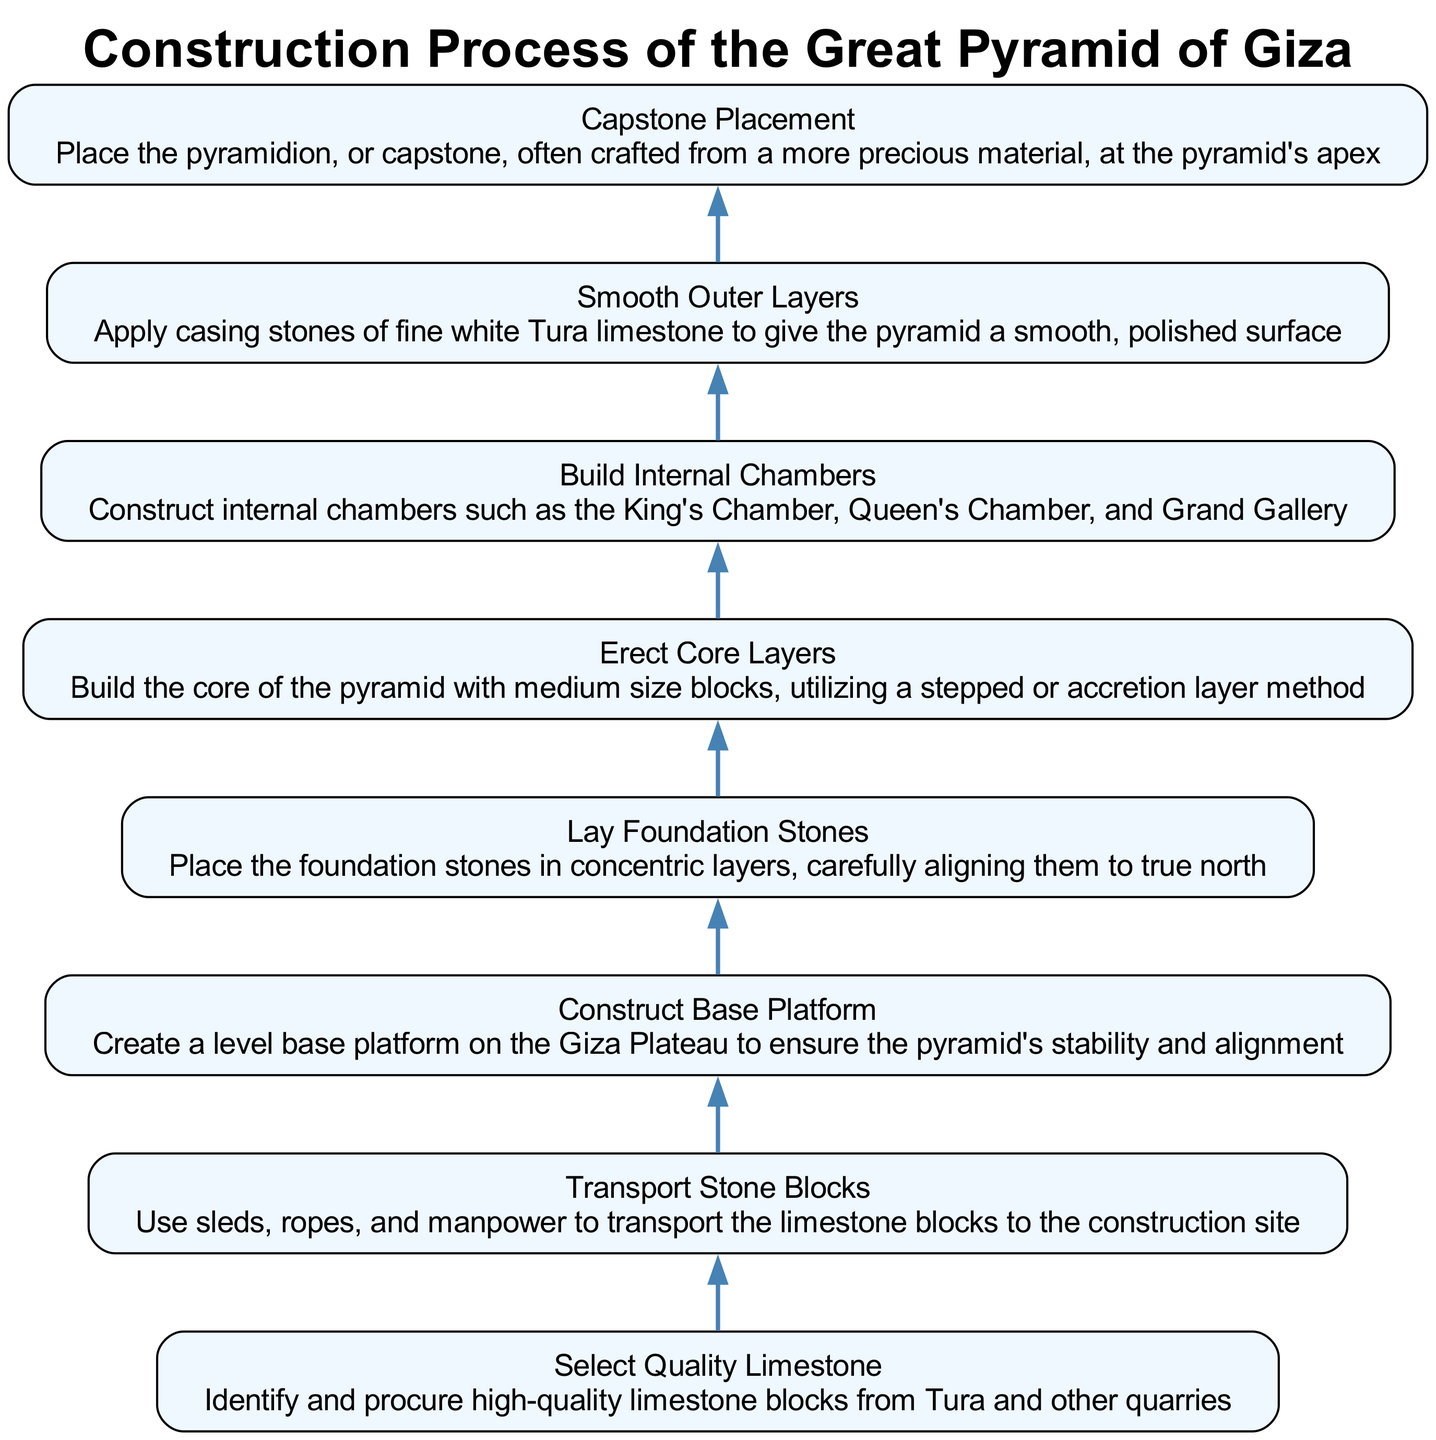What is the first step in the construction process? The first step shown in the diagram is "Select Quality Limestone," which is at the bottom of the flow chart. This indicates that before any other activity can occur, this step must be completed first.
Answer: Select Quality Limestone How many steps are involved in constructing the Great Pyramid? By counting the nodes in the flow chart, we can see there are eight distinct steps listed in the process, which includes each step from selecting limestone to placing the capstone.
Answer: Eight What is the last step in the construction process? The last step, which is at the top of the diagram, is "Capstone Placement." This indicates that after all previous steps are completed, placing the capstone is the final action taken in the construction process.
Answer: Capstone Placement Which step involves laying foundation stones? The specific step that outlines this activity is "Lay Foundation Stones," which comes after constructing the base platform. It mentions placing the foundation in concentric layers and aligning them properly.
Answer: Lay Foundation Stones What is the relationship between "Construct Base Platform" and "Lay Foundation Stones"? The diagram indicates a direct flow where "Construct Base Platform" precedes "Lay Foundation Stones," meaning the base must be created before the foundation stones can be laid.
Answer: Construct Base Platform → Lay Foundation Stones What kind of limestone is used in the smoothing process? The diagram specifies that "Smooth Outer Layers" involves applying casing stones made of fine white Tura limestone, indicating its specific use in providing the polished surface for the pyramid.
Answer: Fine white Tura limestone How does the process of building internal chambers fit into the overall sequence? The "Build Internal Chambers" step is positioned after "Erect Core Layers" and before "Smooth Outer Layers," indicating that these internal constructions occur after the main structure but before the final finishing touches.
Answer: After Erect Core Layers and before Smooth Outer Layers What signifies the completion of the construction process? The diagram implies that the completion is signified by the "Capstone Placement," as this is the final step which concludes the entire construction process.
Answer: Capstone Placement 